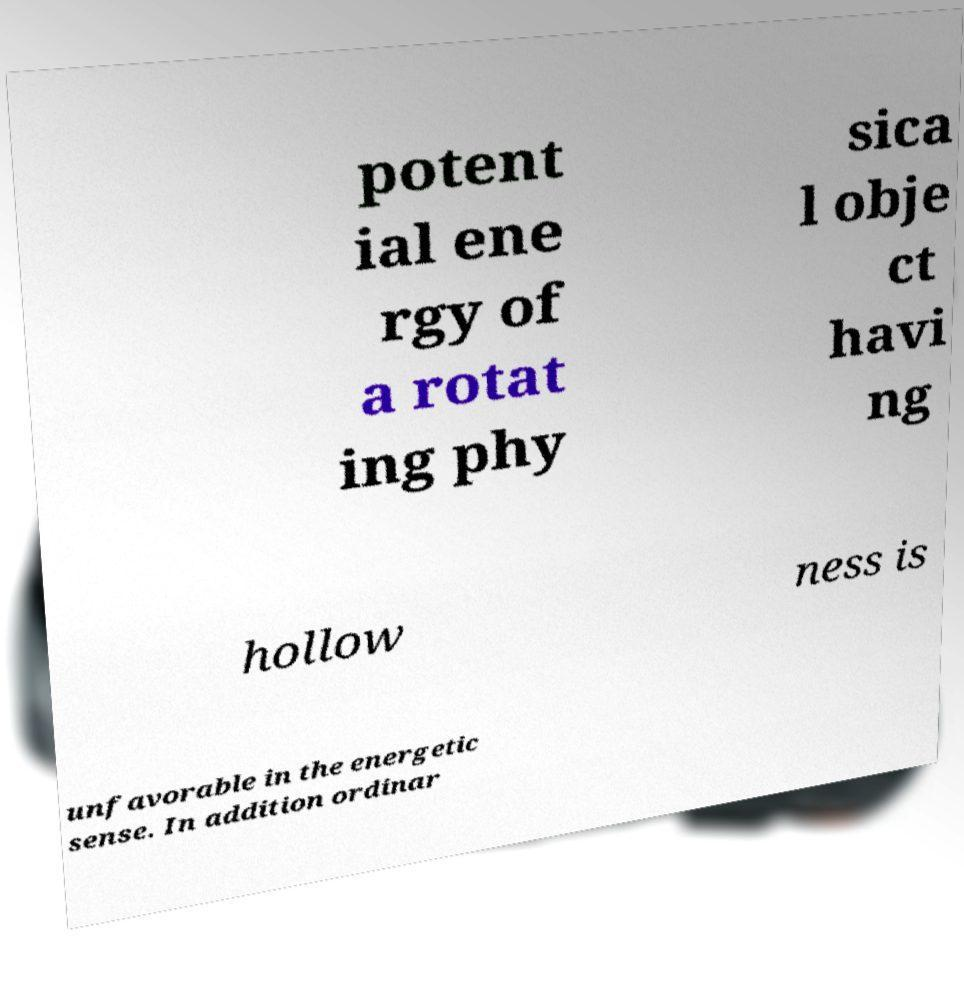Could you extract and type out the text from this image? potent ial ene rgy of a rotat ing phy sica l obje ct havi ng hollow ness is unfavorable in the energetic sense. In addition ordinar 